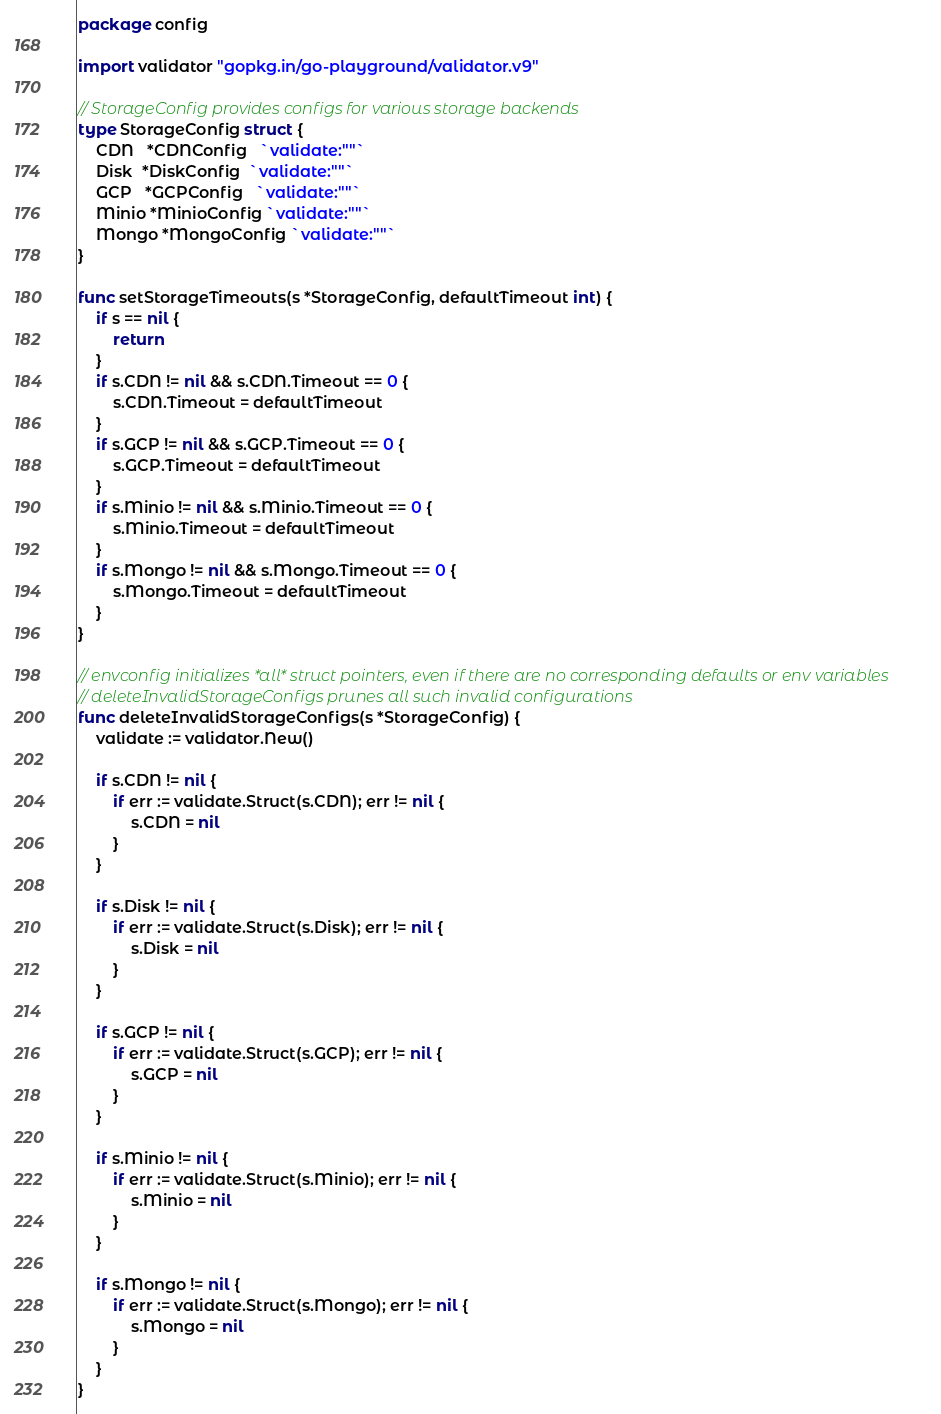<code> <loc_0><loc_0><loc_500><loc_500><_Go_>package config

import validator "gopkg.in/go-playground/validator.v9"

// StorageConfig provides configs for various storage backends
type StorageConfig struct {
	CDN   *CDNConfig   `validate:""`
	Disk  *DiskConfig  `validate:""`
	GCP   *GCPConfig   `validate:""`
	Minio *MinioConfig `validate:""`
	Mongo *MongoConfig `validate:""`
}

func setStorageTimeouts(s *StorageConfig, defaultTimeout int) {
	if s == nil {
		return
	}
	if s.CDN != nil && s.CDN.Timeout == 0 {
		s.CDN.Timeout = defaultTimeout
	}
	if s.GCP != nil && s.GCP.Timeout == 0 {
		s.GCP.Timeout = defaultTimeout
	}
	if s.Minio != nil && s.Minio.Timeout == 0 {
		s.Minio.Timeout = defaultTimeout
	}
	if s.Mongo != nil && s.Mongo.Timeout == 0 {
		s.Mongo.Timeout = defaultTimeout
	}
}

// envconfig initializes *all* struct pointers, even if there are no corresponding defaults or env variables
// deleteInvalidStorageConfigs prunes all such invalid configurations
func deleteInvalidStorageConfigs(s *StorageConfig) {
	validate := validator.New()

	if s.CDN != nil {
		if err := validate.Struct(s.CDN); err != nil {
			s.CDN = nil
		}
	}

	if s.Disk != nil {
		if err := validate.Struct(s.Disk); err != nil {
			s.Disk = nil
		}
	}

	if s.GCP != nil {
		if err := validate.Struct(s.GCP); err != nil {
			s.GCP = nil
		}
	}

	if s.Minio != nil {
		if err := validate.Struct(s.Minio); err != nil {
			s.Minio = nil
		}
	}

	if s.Mongo != nil {
		if err := validate.Struct(s.Mongo); err != nil {
			s.Mongo = nil
		}
	}
}
</code> 